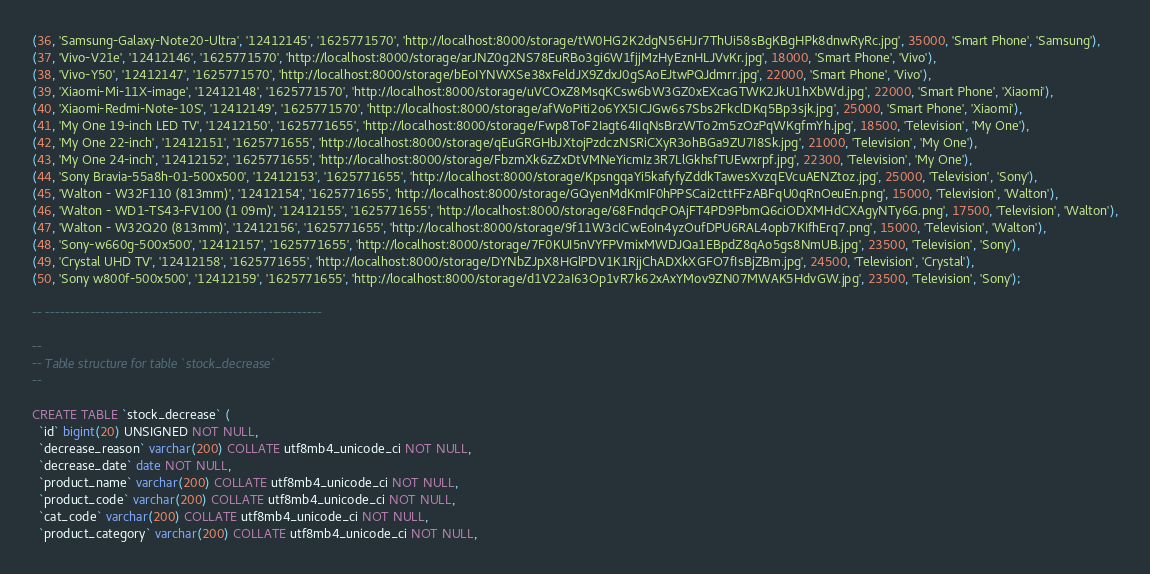<code> <loc_0><loc_0><loc_500><loc_500><_SQL_>(36, 'Samsung-Galaxy-Note20-Ultra', '12412145', '1625771570', 'http://localhost:8000/storage/tW0HG2K2dgN56HJr7ThUi58sBgKBgHPk8dnwRyRc.jpg', 35000, 'Smart Phone', 'Samsung'),
(37, 'Vivo-V21e', '12412146', '1625771570', 'http://localhost:8000/storage/arJNZ0g2NS78EuRBo3gi6W1fjjMzHyEznHLJVvKr.jpg', 18000, 'Smart Phone', 'Vivo'),
(38, 'Vivo-Y50', '12412147', '1625771570', 'http://localhost:8000/storage/bEoIYNWXSe38xFeldJX9ZdxJ0gSAoEJtwPQJdmrr.jpg', 22000, 'Smart Phone', 'Vivo'),
(39, 'Xiaomi-Mi-11X-image', '12412148', '1625771570', 'http://localhost:8000/storage/uVCOxZ8MsqKCsw6bW3GZ0xEXcaGTWK2JkU1hXbWd.jpg', 22000, 'Smart Phone', 'Xiaomi'),
(40, 'Xiaomi-Redmi-Note-10S', '12412149', '1625771570', 'http://localhost:8000/storage/afWoPiti2o6YX5ICJGw6s7Sbs2FkclDKq5Bp3sjk.jpg', 25000, 'Smart Phone', 'Xiaomi'),
(41, 'My One 19-inch LED TV', '12412150', '1625771655', 'http://localhost:8000/storage/Fwp8ToF2Iagt64IIqNsBrzWTo2m5zOzPqWKgfmYh.jpg', 18500, 'Television', 'My One'),
(42, 'My One 22-inch', '12412151', '1625771655', 'http://localhost:8000/storage/qEuGRGHbJXtojPzdczNSRiCXyR3ohBGa9ZU7I8Sk.jpg', 21000, 'Television', 'My One'),
(43, 'My One 24-inch', '12412152', '1625771655', 'http://localhost:8000/storage/FbzmXk6zZxDtVMNeYicmIz3R7LlGkhsfTUEwxrpf.jpg', 22300, 'Television', 'My One'),
(44, 'Sony Bravia-55a8h-01-500x500', '12412153', '1625771655', 'http://localhost:8000/storage/KpsngqaYi5kafyfyZddkTawesXvzqEVcuAENZtoz.jpg', 25000, 'Television', 'Sony'),
(45, 'Walton - W32F110 (813mm)', '12412154', '1625771655', 'http://localhost:8000/storage/GQyenMdKmIF0hPPSCai2cttFFzABFqU0qRnOeuEn.png', 15000, 'Television', 'Walton'),
(46, 'Walton - WD1-TS43-FV100 (1 09m)', '12412155', '1625771655', 'http://localhost:8000/storage/68FndqcPOAjFT4PD9PbmQ6ciODXMHdCXAgyNTy6G.png', 17500, 'Television', 'Walton'),
(47, 'Walton - W32Q20 (813mm)', '12412156', '1625771655', 'http://localhost:8000/storage/9f11W3cICwEoIn4yzOufDPU6RAL4opb7KIfhErq7.png', 15000, 'Television', 'Walton'),
(48, 'Sony-w660g-500x500', '12412157', '1625771655', 'http://localhost:8000/storage/7F0KUI5nVYFPVmixMWDJQa1EBpdZ8qAo5gs8NmUB.jpg', 23500, 'Television', 'Sony'),
(49, 'Crystal UHD TV', '12412158', '1625771655', 'http://localhost:8000/storage/DYNbZJpX8HGlPDV1K1RjjChADXkXGFO7fIsBjZBm.jpg', 24500, 'Television', 'Crystal'),
(50, 'Sony w800f-500x500', '12412159', '1625771655', 'http://localhost:8000/storage/d1V22aI63Op1vR7k62xAxYMov9ZN07MWAK5HdvGW.jpg', 23500, 'Television', 'Sony');

-- --------------------------------------------------------

--
-- Table structure for table `stock_decrease`
--

CREATE TABLE `stock_decrease` (
  `id` bigint(20) UNSIGNED NOT NULL,
  `decrease_reason` varchar(200) COLLATE utf8mb4_unicode_ci NOT NULL,
  `decrease_date` date NOT NULL,
  `product_name` varchar(200) COLLATE utf8mb4_unicode_ci NOT NULL,
  `product_code` varchar(200) COLLATE utf8mb4_unicode_ci NOT NULL,
  `cat_code` varchar(200) COLLATE utf8mb4_unicode_ci NOT NULL,
  `product_category` varchar(200) COLLATE utf8mb4_unicode_ci NOT NULL,</code> 